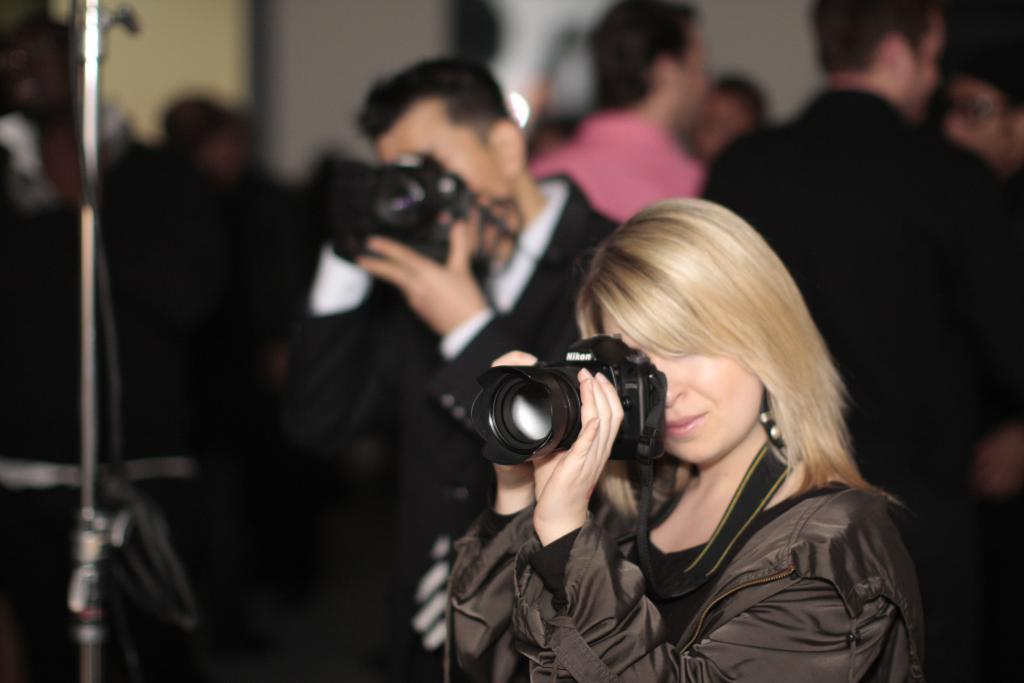Who is the main subject in the image? There is a woman in the image. What is the woman holding in the image? The woman is holding a camera. Can you describe the background of the image? There is a man in the background of the image, and he is also holding a camera. Additionally, there are people standing in the background. What might the people in the background be doing? They might be observing the woman or engaging in their own activities. What type of harmony can be heard in the image? There is no audible sound or music in the image, so it is not possible to determine if there is any harmony present. 